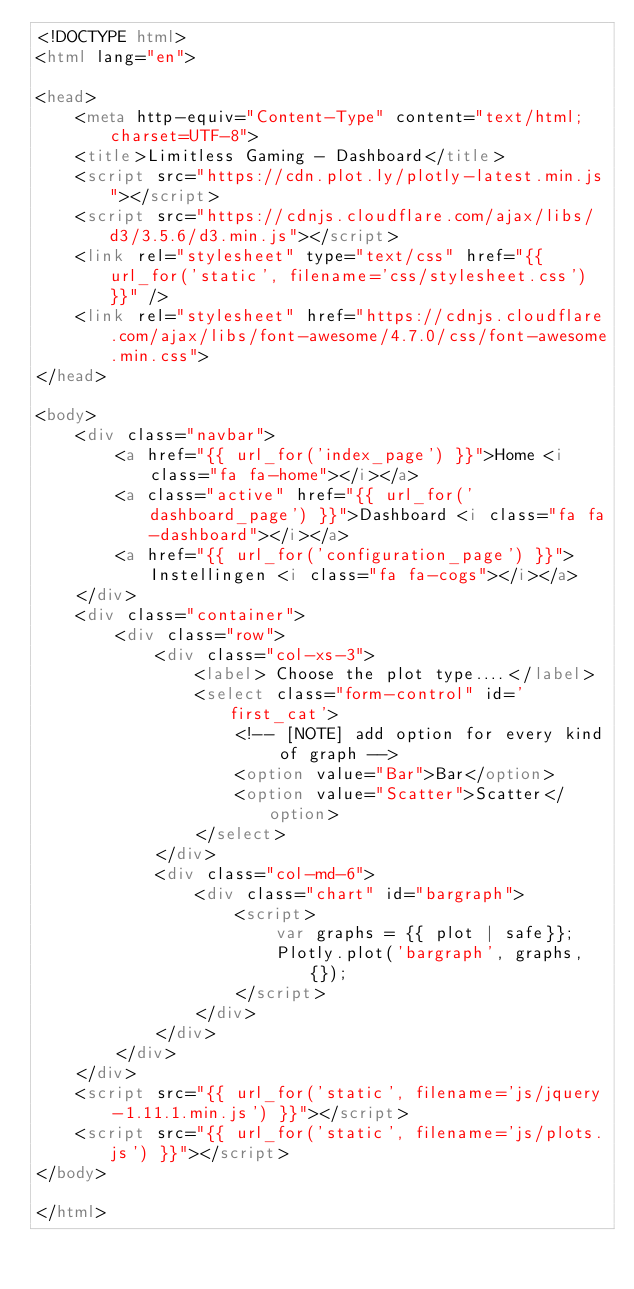<code> <loc_0><loc_0><loc_500><loc_500><_HTML_><!DOCTYPE html>
<html lang="en">

<head>
    <meta http-equiv="Content-Type" content="text/html;charset=UTF-8">
    <title>Limitless Gaming - Dashboard</title>
    <script src="https://cdn.plot.ly/plotly-latest.min.js"></script>
    <script src="https://cdnjs.cloudflare.com/ajax/libs/d3/3.5.6/d3.min.js"></script>
    <link rel="stylesheet" type="text/css" href="{{ url_for('static', filename='css/stylesheet.css') }}" />
    <link rel="stylesheet" href="https://cdnjs.cloudflare.com/ajax/libs/font-awesome/4.7.0/css/font-awesome.min.css">
</head>

<body>
    <div class="navbar">
        <a href="{{ url_for('index_page') }}">Home <i class="fa fa-home"></i></a>
        <a class="active" href="{{ url_for('dashboard_page') }}">Dashboard <i class="fa fa-dashboard"></i></a>
        <a href="{{ url_for('configuration_page') }}">Instellingen <i class="fa fa-cogs"></i></a>
    </div>
    <div class="container">
        <div class="row">
            <div class="col-xs-3">
                <label> Choose the plot type....</label>
                <select class="form-control" id='first_cat'>
                    <!-- [NOTE] add option for every kind of graph -->
                    <option value="Bar">Bar</option>
                    <option value="Scatter">Scatter</option>
                </select>
            </div>
            <div class="col-md-6">
                <div class="chart" id="bargraph">
                    <script>
                        var graphs = {{ plot | safe}};
                        Plotly.plot('bargraph', graphs, {});
                    </script>
                </div>
            </div>
        </div>
    </div>
    <script src="{{ url_for('static', filename='js/jquery-1.11.1.min.js') }}"></script>
    <script src="{{ url_for('static', filename='js/plots.js') }}"></script>
</body>

</html></code> 